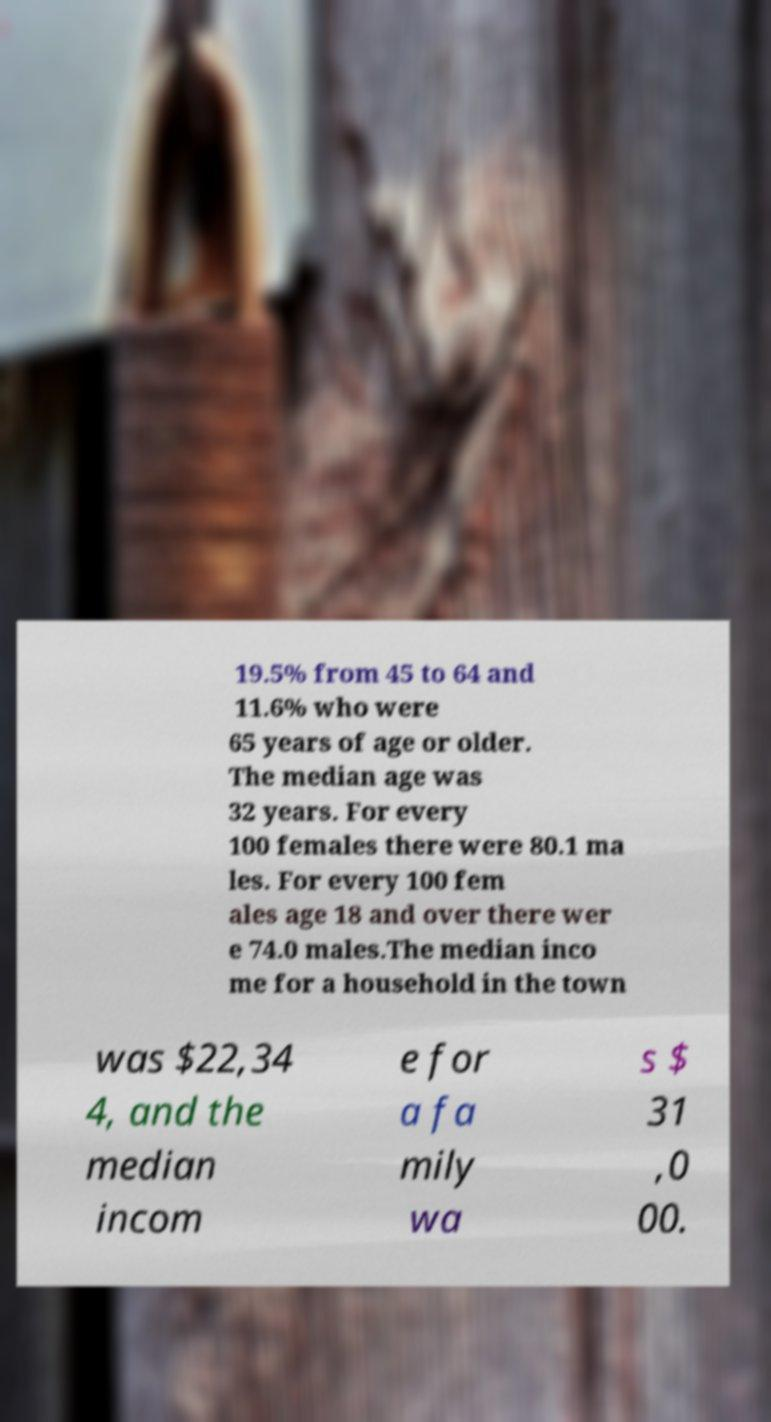I need the written content from this picture converted into text. Can you do that? 19.5% from 45 to 64 and 11.6% who were 65 years of age or older. The median age was 32 years. For every 100 females there were 80.1 ma les. For every 100 fem ales age 18 and over there wer e 74.0 males.The median inco me for a household in the town was $22,34 4, and the median incom e for a fa mily wa s $ 31 ,0 00. 